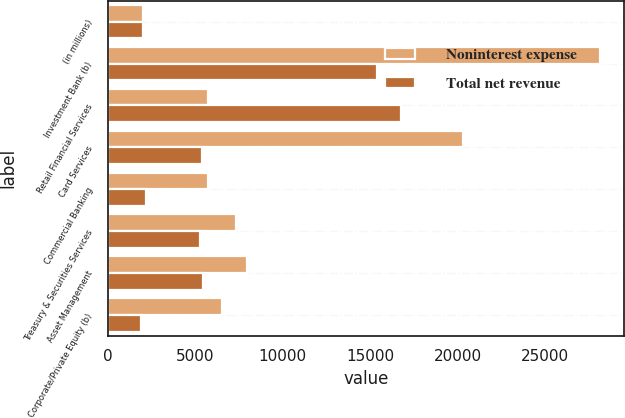Convert chart to OTSL. <chart><loc_0><loc_0><loc_500><loc_500><stacked_bar_chart><ecel><fcel>(in millions)<fcel>Investment Bank (b)<fcel>Retail Financial Services<fcel>Card Services<fcel>Commercial Banking<fcel>Treasury & Securities Services<fcel>Asset Management<fcel>Corporate/Private Equity (b)<nl><fcel>Noninterest expense<fcel>2009<fcel>28109<fcel>5720<fcel>20304<fcel>5720<fcel>7344<fcel>7965<fcel>6513<nl><fcel>Total net revenue<fcel>2009<fcel>15401<fcel>16748<fcel>5381<fcel>2176<fcel>5278<fcel>5473<fcel>1895<nl></chart> 